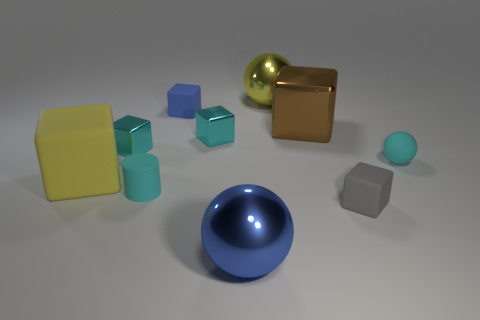Are there any tiny objects that are in front of the small cyan rubber thing on the left side of the tiny sphere?
Provide a succinct answer. Yes. What number of other things are there of the same color as the tiny ball?
Your response must be concise. 3. The small cylinder has what color?
Give a very brief answer. Cyan. There is a rubber cube that is both behind the small gray matte thing and in front of the big brown object; how big is it?
Make the answer very short. Large. What number of objects are either matte things that are to the left of the yellow metal ball or cyan matte balls?
Offer a very short reply. 4. What shape is the yellow object that is the same material as the brown cube?
Offer a terse response. Sphere. There is a gray object; what shape is it?
Offer a terse response. Cube. What is the color of the cube that is in front of the cyan sphere and on the left side of the tiny blue matte cube?
Ensure brevity in your answer.  Yellow. What shape is the yellow thing that is the same size as the yellow ball?
Keep it short and to the point. Cube. Is there a yellow metal object of the same shape as the brown metal thing?
Provide a succinct answer. No. 